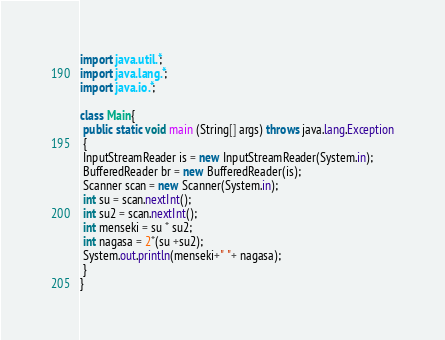<code> <loc_0><loc_0><loc_500><loc_500><_Java_>import java.util.*;
import java.lang.*;
import java.io.*;

class Main{
 public static void main (String[] args) throws java.lang.Exception
 {
 InputStreamReader is = new InputStreamReader(System.in);
 BufferedReader br = new BufferedReader(is);
 Scanner scan = new Scanner(System.in);
 int su = scan.nextInt();
 int su2 = scan.nextInt();
 int menseki = su * su2;
 int nagasa = 2*(su +su2);
 System.out.println(menseki+" "+ nagasa);
 }
}
</code> 